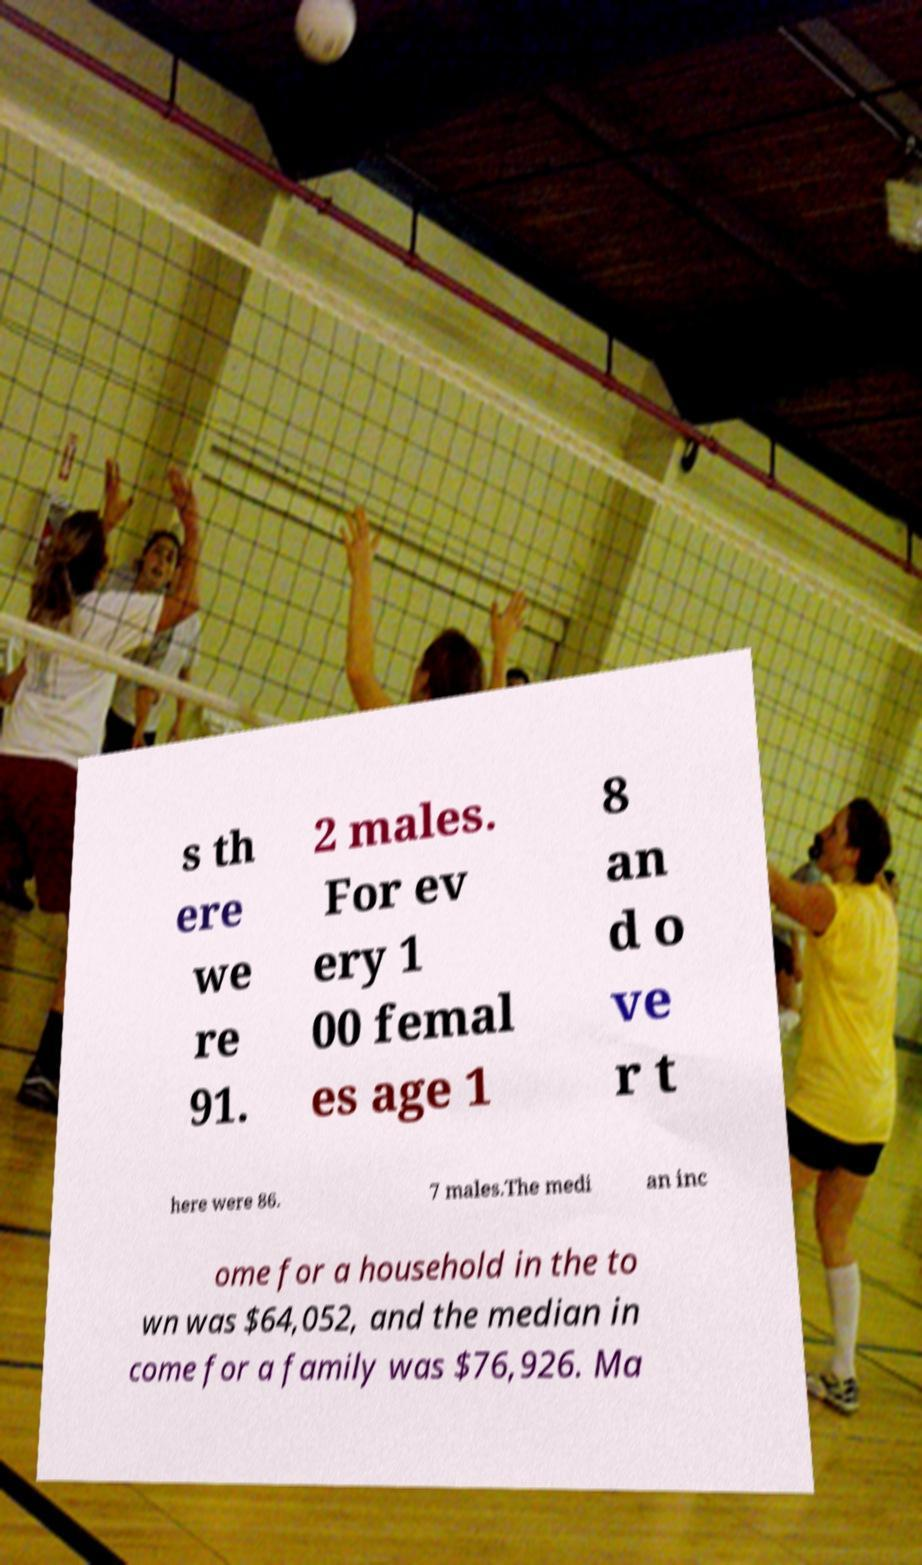Please identify and transcribe the text found in this image. s th ere we re 91. 2 males. For ev ery 1 00 femal es age 1 8 an d o ve r t here were 86. 7 males.The medi an inc ome for a household in the to wn was $64,052, and the median in come for a family was $76,926. Ma 